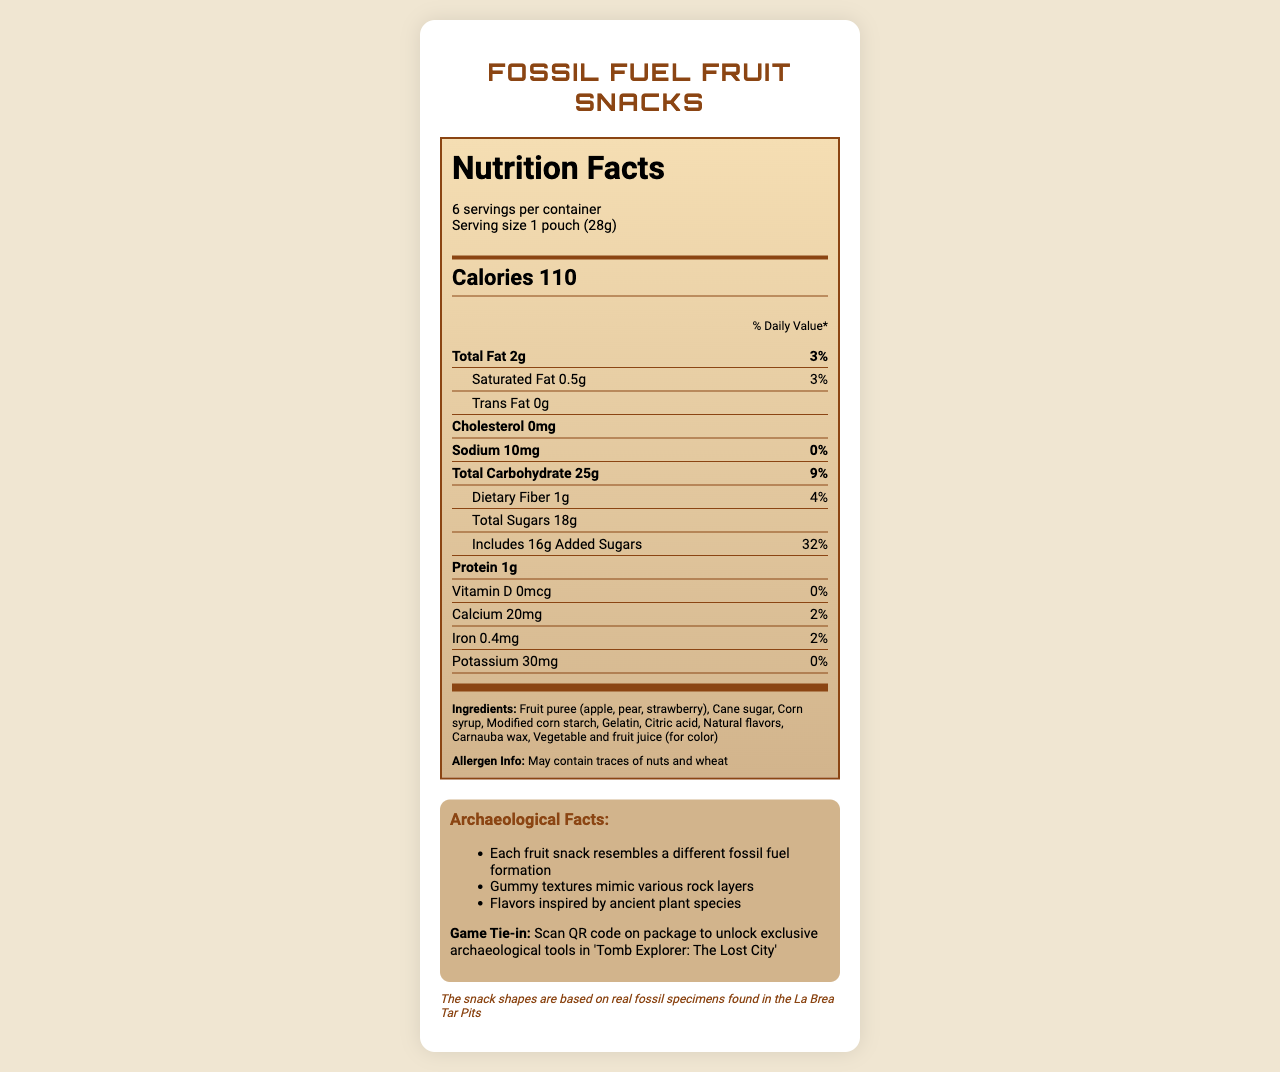what is the serving size? The serving size is stated in the nutrition facts section as "1 pouch (28g)."
Answer: 1 pouch (28g) how many servings are in the container? The document mentions there are 6 servings per container.
Answer: 6 how much total fat is in one serving? The total fat content per serving is listed as "2g."
Answer: 2g what is the daily value percentage of added sugars per serving? The '% Daily Value' for added sugars per serving is provided as "32%."
Answer: 32% what is the amount of dietary fiber in one serving? The dietary fiber content per serving is listed as "1g."
Answer: 1g how many calories are in a serving of Fossil Fuel Fruit Snacks? The calorie content per serving is listed as 110 calories.
Answer: 110 calories which of the following nutrients does not have any daily value percentage? A. Iron B. Sodium C. Vitamin D D. Protein Vitamin D has a daily value percentage of 0%.
Answer: C what are the ingredients listed in the product? The ingredients are listed at the bottom of the nutrition label section.
Answer: Fruit puree (apple, pear, strawberry), Cane sugar, Corn syrup, Modified corn starch, Gelatin, Citric acid, Natural flavors, Carnauba wax, Vegetable and fruit juice (for color) does the product contain any allergens? The allergen information is mentioned under the ingredients section.
Answer: May contain traces of nuts and wheat how are the archaeological facts related to the fruit snacks? The archaeological facts are described in detail under the "Archaeological Facts" section.
Answer: Each fruit snack resembles a different fossil fuel formation, Gummy textures mimic various rock layers, Flavors inspired by ancient plant species what is the fun fact about the snack shapes? The fun fact is mentioned at the bottom, indicating the snack shapes mimic real fossil specimens from the La Brea Tar Pits.
Answer: The snack shapes are based on real fossil specimens found in the La Brea Tar Pits what is the game tie-in feature of the product? The game tie-in is described in the archaeological facts section where scanning the QR code unlocks tools in "Tomb Explorer: The Lost City."
Answer: Scan QR code on package to unlock exclusive archaeological tools in 'Tomb Explorer: The Lost City' does this document provide instructions for how to consume the fruit snacks? The document does not contain any instructions on how to consume the fruit snacks.
Answer: No summarize the main idea of the document The document provides a comprehensive view of the nutritional, ingredient, and fun archaeological aspects of the Fossil Fuel Fruit Snacks, along with information on the game tie-in and packaging theme.
Answer: The document provides nutritional information about Fossil Fuel Fruit Snacks, listing calories, fat content, and other dietary components. It details the ingredients and potential allergens. Additionally, it includes fun archaeological facts about the snack shapes and a game feature tie-in. The packaging is themed like a geological cross-section. how many milligrams of calcium are there per serving? The calcium content per serving is listed as "20mg."
Answer: 20mg what is the total carbohydrate content per serving? The total carbohydrate content is listed as "25g."
Answer: 25g how much vitamin D is in one serving? The vitamin D content is indicated as "0mcg."
Answer: 0mcg are the flavors of the fruit snacks inspired by ancient plant species? One of the archaeological facts mentions that the flavors are inspired by ancient plant species.
Answer: Yes 